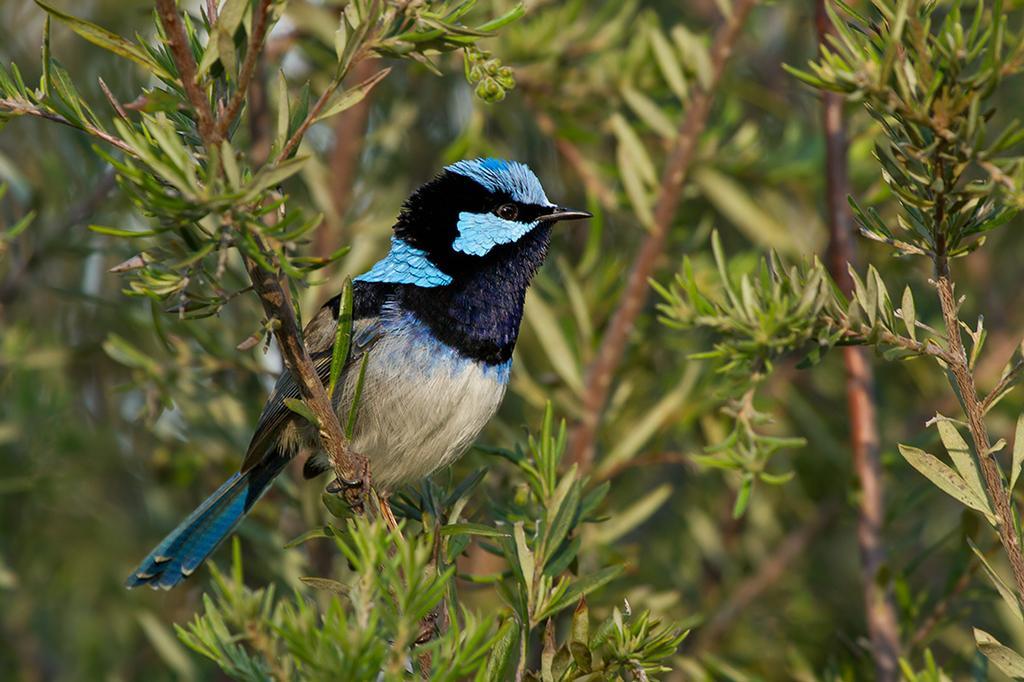Please provide a concise description of this image. In this image we can see a bird on a plant. In the background the image is blur but we can see plants. 